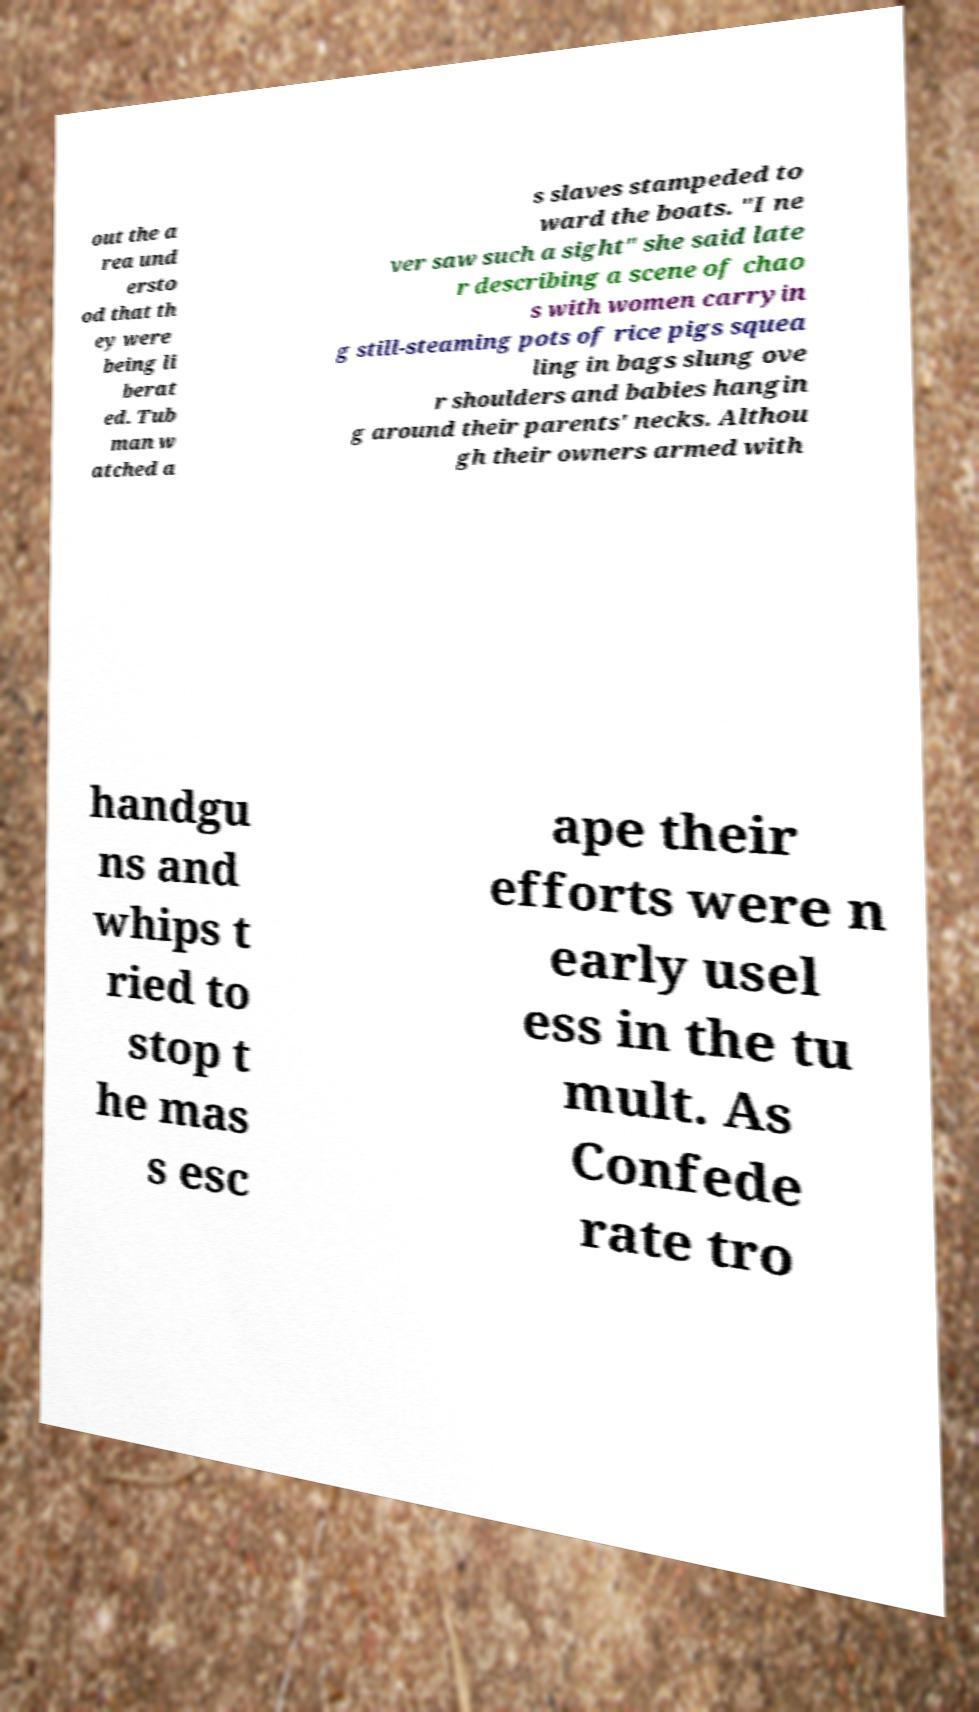Could you assist in decoding the text presented in this image and type it out clearly? out the a rea und ersto od that th ey were being li berat ed. Tub man w atched a s slaves stampeded to ward the boats. "I ne ver saw such a sight" she said late r describing a scene of chao s with women carryin g still-steaming pots of rice pigs squea ling in bags slung ove r shoulders and babies hangin g around their parents' necks. Althou gh their owners armed with handgu ns and whips t ried to stop t he mas s esc ape their efforts were n early usel ess in the tu mult. As Confede rate tro 